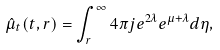<formula> <loc_0><loc_0><loc_500><loc_500>\hat { \mu } _ { t } ( t , r ) = \int _ { r } ^ { \infty } 4 \pi j e ^ { 2 \lambda } e ^ { \mu + \lambda } d \eta ,</formula> 